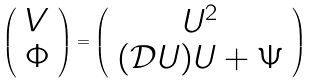Convert formula to latex. <formula><loc_0><loc_0><loc_500><loc_500>\left ( \begin{array} { c } V \\ \Phi \end{array} \right ) = \left ( \begin{array} { c } U ^ { 2 } \\ ( \mathcal { D } U ) U + \Psi \end{array} \right )</formula> 